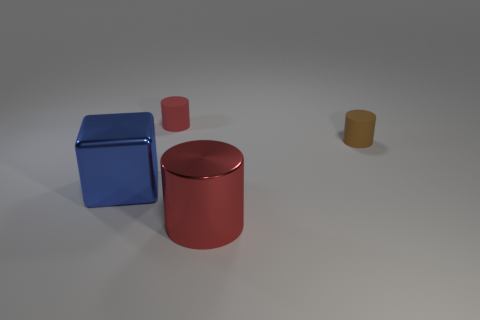Add 4 red matte cylinders. How many objects exist? 8 Subtract all cylinders. How many objects are left? 1 Subtract 2 red cylinders. How many objects are left? 2 Subtract all brown rubber objects. Subtract all cyan matte cubes. How many objects are left? 3 Add 3 big cubes. How many big cubes are left? 4 Add 1 big blue things. How many big blue things exist? 2 